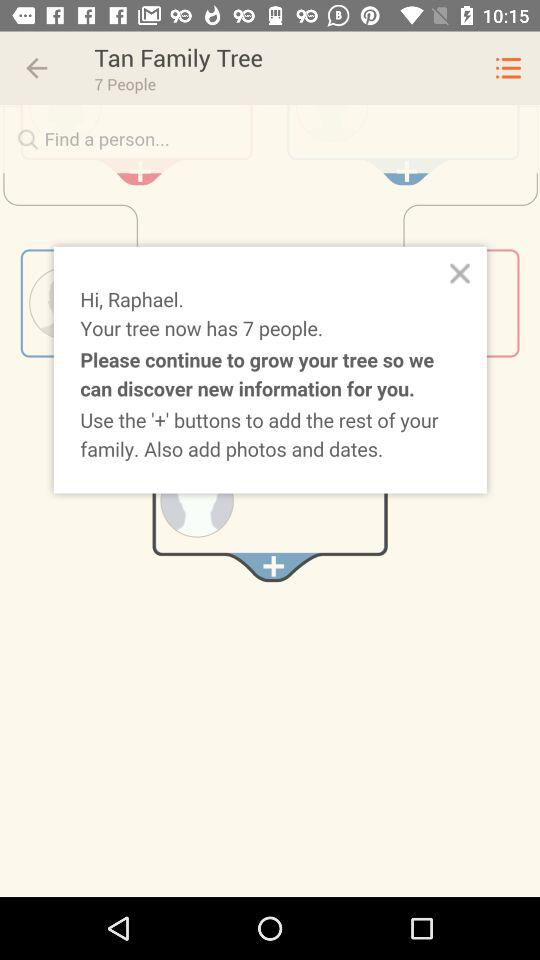How many people did the Tan family tree have? The Tan family tree has 7 people. 